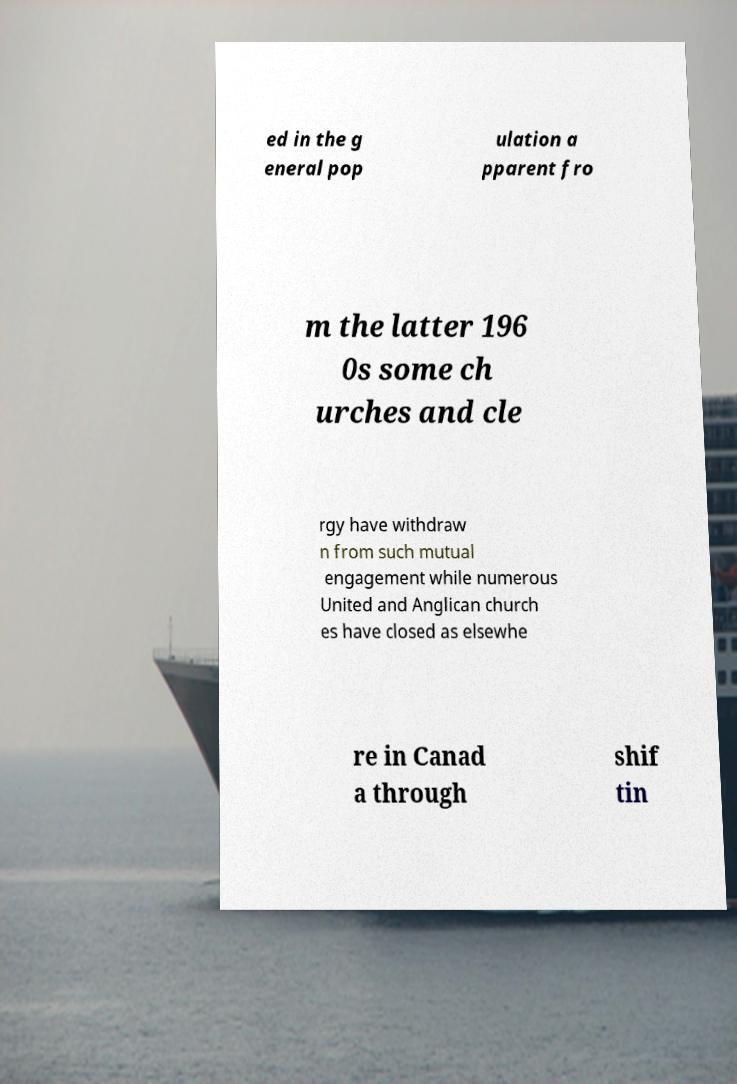For documentation purposes, I need the text within this image transcribed. Could you provide that? ed in the g eneral pop ulation a pparent fro m the latter 196 0s some ch urches and cle rgy have withdraw n from such mutual engagement while numerous United and Anglican church es have closed as elsewhe re in Canad a through shif tin 